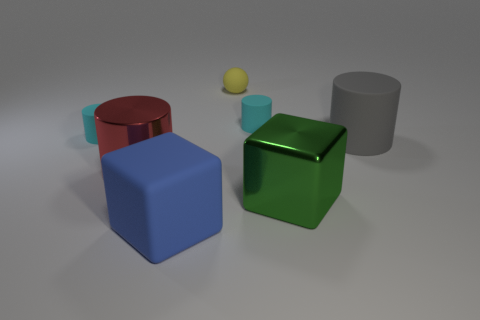There is a small ball; does it have the same color as the big metallic object to the left of the sphere?
Make the answer very short. No. Is the number of small yellow rubber things greater than the number of blue metallic objects?
Keep it short and to the point. Yes. What size is the other object that is the same shape as the large blue thing?
Offer a terse response. Large. Are the blue object and the cylinder that is in front of the big gray object made of the same material?
Your answer should be compact. No. How many objects are either cyan cylinders or big green matte cubes?
Offer a terse response. 2. Does the cyan cylinder to the left of the tiny yellow ball have the same size as the red thing that is to the left of the tiny yellow matte thing?
Give a very brief answer. No. What number of balls are either tiny yellow matte objects or red objects?
Offer a very short reply. 1. Are any gray matte cylinders visible?
Offer a terse response. Yes. Is there any other thing that has the same shape as the red metallic object?
Your answer should be very brief. Yes. Is the color of the rubber ball the same as the matte block?
Provide a short and direct response. No. 